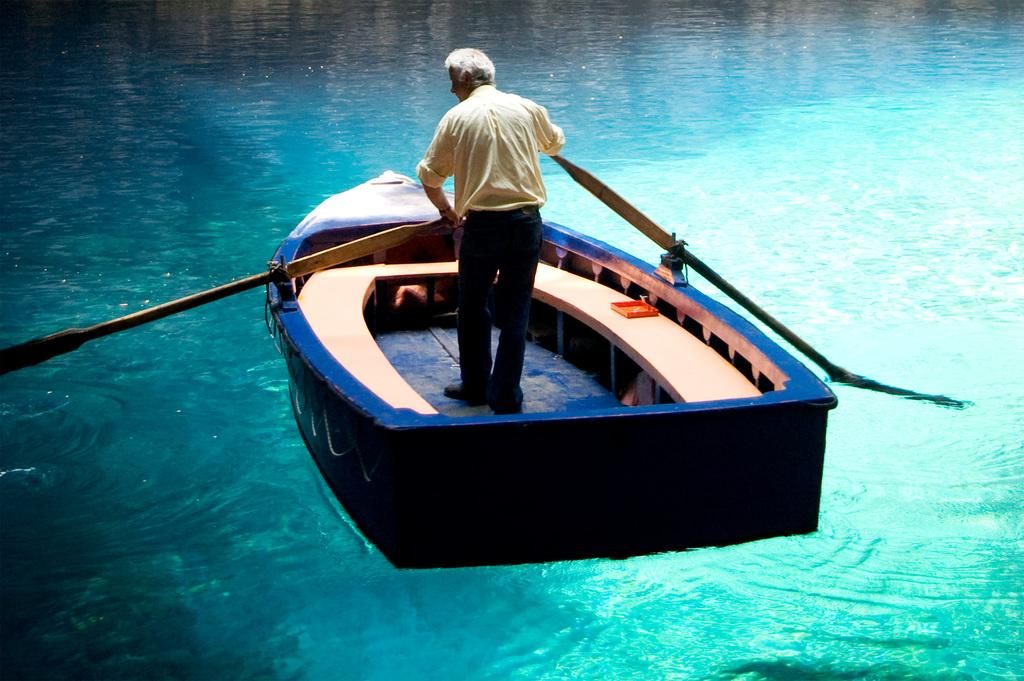What is the main subject of the image? The main subject of the image is a boat. Where is the boat located? The boat is on water. Is there anyone in the boat? Yes, there is a person in the boat. What is the person in the boat doing? The person is standing and holding pedals. How much does the person's dad weigh in the image? There is no information about the person's dad in the image, so we cannot determine their weight. 